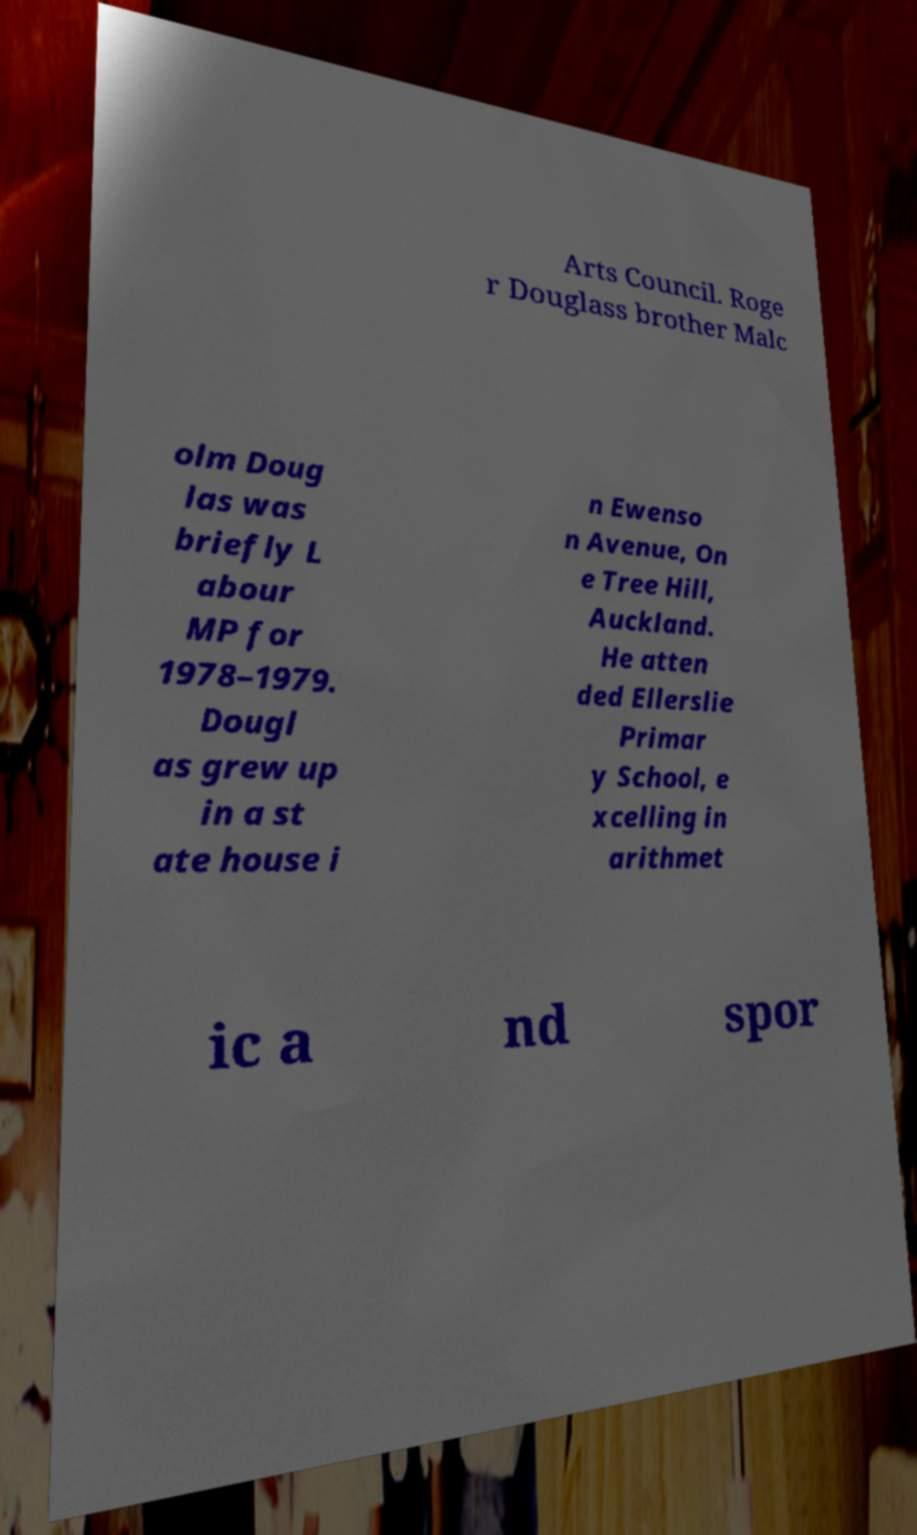Please read and relay the text visible in this image. What does it say? Arts Council. Roge r Douglass brother Malc olm Doug las was briefly L abour MP for 1978–1979. Dougl as grew up in a st ate house i n Ewenso n Avenue, On e Tree Hill, Auckland. He atten ded Ellerslie Primar y School, e xcelling in arithmet ic a nd spor 